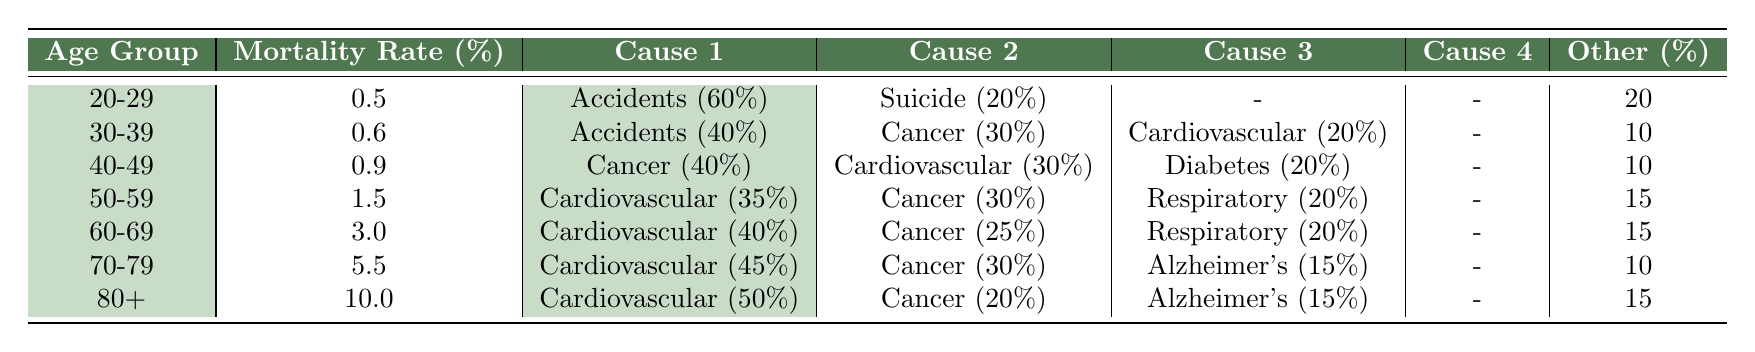What is the estimated mortality rate for the age group 50-59? The table states that the estimated mortality rate for the age group 50-59 is listed directly in the table.
Answer: 1.5 Which age group has the highest estimated mortality rate? By reviewing the table, we see that the age group 80+ has the highest estimated mortality rate at 10.0%.
Answer: 80+ What percentage of deaths in the age group 30-39 are attributed to accidents? In the table for the age group 30-39, the cause of death due to accidents is mentioned as 40%, so this is the direct retrieval from the table.
Answer: 40% Is it true that cardiovascular disease is the leading cause of death for individuals aged 40-49? When examining the table for the age group 40-49, cardiovascular disease accounts for 30% of deaths, which is less than cancer at 40%. This means cardiovascular disease is not the leading cause of death for this age group.
Answer: No What is the difference in mortality rates between the age groups 20-29 and 60-69? The mortality rate for the age group 20-29 is 0.5%, and for 60-69 is 3.0%. The difference is 3.0 - 0.5 = 2.5%.
Answer: 2.5 If a person is within the age group 70-79, what is the combined percentage of deaths caused by cancer and Alzheimer's? The age group 70-79 shows that cancer accounts for 30% and Alzheimer's 15%. To find the combined percentage, we add these two percentages: 30% + 15% = 45%.
Answer: 45% Among all age groups, which cause of death appears most frequently as the top cause? By analyzing the table, cardiovascular disease is the top cause of death in four out of the seven age groups. This indicates it is the most frequently occurring top cause across the intervals.
Answer: Cardiovascular What is the average estimated mortality rate for the age groups 30-39 and 50-59? The mortality rates for these age groups are 0.6% and 1.5%, respectively. To find the average, we add them: 0.6 + 1.5 = 2.1%. Then, since there are two age groups, we divide by 2: 2.1 / 2 = 1.05%.
Answer: 1.05 How many age groups have a mortality rate greater than 3%? Looking at the mortality rates in the table, 60-69, 70-79, and 80+ have rates greater than 3%. Counting these age groups gives us three.
Answer: 3 